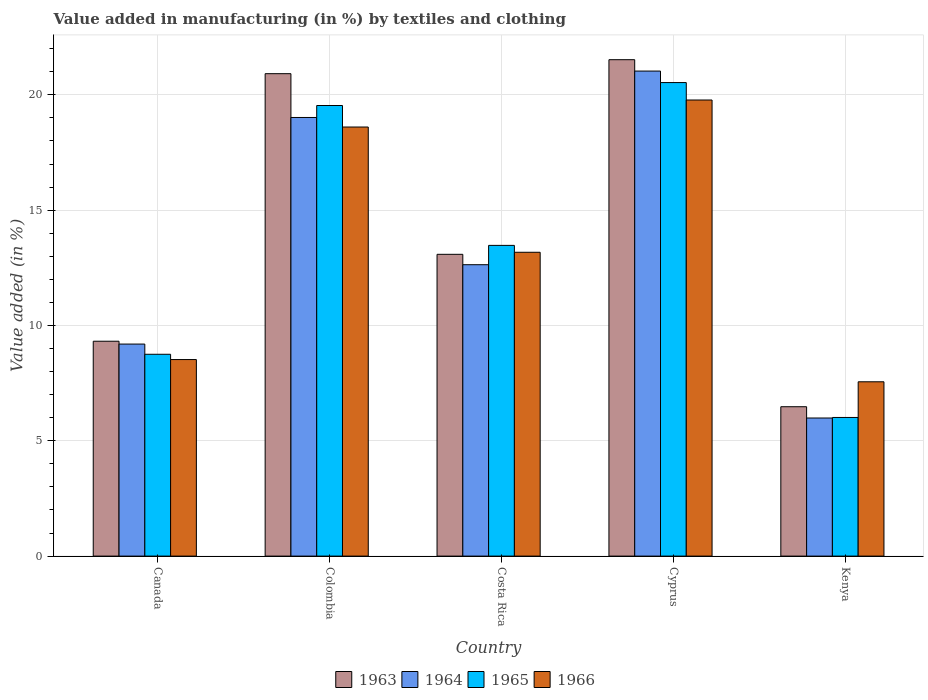Are the number of bars on each tick of the X-axis equal?
Your answer should be compact. Yes. How many bars are there on the 1st tick from the left?
Make the answer very short. 4. What is the label of the 4th group of bars from the left?
Offer a very short reply. Cyprus. What is the percentage of value added in manufacturing by textiles and clothing in 1963 in Cyprus?
Make the answer very short. 21.52. Across all countries, what is the maximum percentage of value added in manufacturing by textiles and clothing in 1966?
Your response must be concise. 19.78. Across all countries, what is the minimum percentage of value added in manufacturing by textiles and clothing in 1966?
Your answer should be very brief. 7.56. In which country was the percentage of value added in manufacturing by textiles and clothing in 1965 maximum?
Offer a terse response. Cyprus. In which country was the percentage of value added in manufacturing by textiles and clothing in 1966 minimum?
Provide a short and direct response. Kenya. What is the total percentage of value added in manufacturing by textiles and clothing in 1963 in the graph?
Your response must be concise. 71.32. What is the difference between the percentage of value added in manufacturing by textiles and clothing in 1966 in Canada and that in Costa Rica?
Ensure brevity in your answer.  -4.65. What is the difference between the percentage of value added in manufacturing by textiles and clothing in 1963 in Kenya and the percentage of value added in manufacturing by textiles and clothing in 1966 in Colombia?
Offer a terse response. -12.13. What is the average percentage of value added in manufacturing by textiles and clothing in 1964 per country?
Ensure brevity in your answer.  13.57. What is the difference between the percentage of value added in manufacturing by textiles and clothing of/in 1963 and percentage of value added in manufacturing by textiles and clothing of/in 1965 in Colombia?
Offer a terse response. 1.38. What is the ratio of the percentage of value added in manufacturing by textiles and clothing in 1966 in Colombia to that in Costa Rica?
Offer a terse response. 1.41. Is the difference between the percentage of value added in manufacturing by textiles and clothing in 1963 in Colombia and Kenya greater than the difference between the percentage of value added in manufacturing by textiles and clothing in 1965 in Colombia and Kenya?
Provide a short and direct response. Yes. What is the difference between the highest and the second highest percentage of value added in manufacturing by textiles and clothing in 1964?
Provide a short and direct response. 6.38. What is the difference between the highest and the lowest percentage of value added in manufacturing by textiles and clothing in 1965?
Provide a short and direct response. 14.52. Is it the case that in every country, the sum of the percentage of value added in manufacturing by textiles and clothing in 1965 and percentage of value added in manufacturing by textiles and clothing in 1966 is greater than the sum of percentage of value added in manufacturing by textiles and clothing in 1964 and percentage of value added in manufacturing by textiles and clothing in 1963?
Offer a very short reply. No. What does the 3rd bar from the left in Costa Rica represents?
Make the answer very short. 1965. What does the 3rd bar from the right in Costa Rica represents?
Offer a terse response. 1964. Is it the case that in every country, the sum of the percentage of value added in manufacturing by textiles and clothing in 1963 and percentage of value added in manufacturing by textiles and clothing in 1965 is greater than the percentage of value added in manufacturing by textiles and clothing in 1964?
Offer a very short reply. Yes. How many bars are there?
Offer a very short reply. 20. Are all the bars in the graph horizontal?
Offer a very short reply. No. Are the values on the major ticks of Y-axis written in scientific E-notation?
Make the answer very short. No. Does the graph contain grids?
Make the answer very short. Yes. How many legend labels are there?
Your answer should be very brief. 4. What is the title of the graph?
Provide a short and direct response. Value added in manufacturing (in %) by textiles and clothing. Does "1969" appear as one of the legend labels in the graph?
Your answer should be compact. No. What is the label or title of the X-axis?
Your answer should be compact. Country. What is the label or title of the Y-axis?
Provide a succinct answer. Value added (in %). What is the Value added (in %) of 1963 in Canada?
Your response must be concise. 9.32. What is the Value added (in %) of 1964 in Canada?
Your response must be concise. 9.19. What is the Value added (in %) of 1965 in Canada?
Keep it short and to the point. 8.75. What is the Value added (in %) in 1966 in Canada?
Make the answer very short. 8.52. What is the Value added (in %) of 1963 in Colombia?
Offer a very short reply. 20.92. What is the Value added (in %) of 1964 in Colombia?
Provide a short and direct response. 19.02. What is the Value added (in %) in 1965 in Colombia?
Your answer should be compact. 19.54. What is the Value added (in %) in 1966 in Colombia?
Keep it short and to the point. 18.6. What is the Value added (in %) in 1963 in Costa Rica?
Your answer should be very brief. 13.08. What is the Value added (in %) of 1964 in Costa Rica?
Make the answer very short. 12.63. What is the Value added (in %) in 1965 in Costa Rica?
Your response must be concise. 13.47. What is the Value added (in %) in 1966 in Costa Rica?
Give a very brief answer. 13.17. What is the Value added (in %) of 1963 in Cyprus?
Your answer should be compact. 21.52. What is the Value added (in %) in 1964 in Cyprus?
Provide a succinct answer. 21.03. What is the Value added (in %) of 1965 in Cyprus?
Offer a terse response. 20.53. What is the Value added (in %) in 1966 in Cyprus?
Keep it short and to the point. 19.78. What is the Value added (in %) of 1963 in Kenya?
Make the answer very short. 6.48. What is the Value added (in %) in 1964 in Kenya?
Provide a short and direct response. 5.99. What is the Value added (in %) of 1965 in Kenya?
Keep it short and to the point. 6.01. What is the Value added (in %) in 1966 in Kenya?
Offer a very short reply. 7.56. Across all countries, what is the maximum Value added (in %) in 1963?
Make the answer very short. 21.52. Across all countries, what is the maximum Value added (in %) in 1964?
Ensure brevity in your answer.  21.03. Across all countries, what is the maximum Value added (in %) of 1965?
Offer a terse response. 20.53. Across all countries, what is the maximum Value added (in %) of 1966?
Offer a terse response. 19.78. Across all countries, what is the minimum Value added (in %) of 1963?
Offer a terse response. 6.48. Across all countries, what is the minimum Value added (in %) of 1964?
Your answer should be very brief. 5.99. Across all countries, what is the minimum Value added (in %) of 1965?
Offer a terse response. 6.01. Across all countries, what is the minimum Value added (in %) of 1966?
Your answer should be compact. 7.56. What is the total Value added (in %) of 1963 in the graph?
Give a very brief answer. 71.32. What is the total Value added (in %) in 1964 in the graph?
Give a very brief answer. 67.86. What is the total Value added (in %) of 1965 in the graph?
Ensure brevity in your answer.  68.3. What is the total Value added (in %) in 1966 in the graph?
Provide a short and direct response. 67.63. What is the difference between the Value added (in %) in 1963 in Canada and that in Colombia?
Keep it short and to the point. -11.6. What is the difference between the Value added (in %) in 1964 in Canada and that in Colombia?
Offer a very short reply. -9.82. What is the difference between the Value added (in %) in 1965 in Canada and that in Colombia?
Offer a very short reply. -10.79. What is the difference between the Value added (in %) in 1966 in Canada and that in Colombia?
Make the answer very short. -10.08. What is the difference between the Value added (in %) of 1963 in Canada and that in Costa Rica?
Provide a succinct answer. -3.77. What is the difference between the Value added (in %) of 1964 in Canada and that in Costa Rica?
Your response must be concise. -3.44. What is the difference between the Value added (in %) of 1965 in Canada and that in Costa Rica?
Your response must be concise. -4.72. What is the difference between the Value added (in %) in 1966 in Canada and that in Costa Rica?
Offer a very short reply. -4.65. What is the difference between the Value added (in %) of 1963 in Canada and that in Cyprus?
Ensure brevity in your answer.  -12.21. What is the difference between the Value added (in %) of 1964 in Canada and that in Cyprus?
Your response must be concise. -11.84. What is the difference between the Value added (in %) in 1965 in Canada and that in Cyprus?
Provide a short and direct response. -11.78. What is the difference between the Value added (in %) in 1966 in Canada and that in Cyprus?
Your response must be concise. -11.25. What is the difference between the Value added (in %) in 1963 in Canada and that in Kenya?
Your answer should be compact. 2.84. What is the difference between the Value added (in %) in 1964 in Canada and that in Kenya?
Keep it short and to the point. 3.21. What is the difference between the Value added (in %) of 1965 in Canada and that in Kenya?
Give a very brief answer. 2.74. What is the difference between the Value added (in %) of 1966 in Canada and that in Kenya?
Offer a terse response. 0.96. What is the difference between the Value added (in %) in 1963 in Colombia and that in Costa Rica?
Your answer should be compact. 7.83. What is the difference between the Value added (in %) of 1964 in Colombia and that in Costa Rica?
Your answer should be compact. 6.38. What is the difference between the Value added (in %) of 1965 in Colombia and that in Costa Rica?
Provide a succinct answer. 6.06. What is the difference between the Value added (in %) of 1966 in Colombia and that in Costa Rica?
Make the answer very short. 5.43. What is the difference between the Value added (in %) in 1963 in Colombia and that in Cyprus?
Provide a short and direct response. -0.61. What is the difference between the Value added (in %) of 1964 in Colombia and that in Cyprus?
Ensure brevity in your answer.  -2.01. What is the difference between the Value added (in %) of 1965 in Colombia and that in Cyprus?
Ensure brevity in your answer.  -0.99. What is the difference between the Value added (in %) of 1966 in Colombia and that in Cyprus?
Provide a succinct answer. -1.17. What is the difference between the Value added (in %) of 1963 in Colombia and that in Kenya?
Offer a terse response. 14.44. What is the difference between the Value added (in %) in 1964 in Colombia and that in Kenya?
Give a very brief answer. 13.03. What is the difference between the Value added (in %) in 1965 in Colombia and that in Kenya?
Your answer should be compact. 13.53. What is the difference between the Value added (in %) in 1966 in Colombia and that in Kenya?
Offer a very short reply. 11.05. What is the difference between the Value added (in %) in 1963 in Costa Rica and that in Cyprus?
Offer a terse response. -8.44. What is the difference between the Value added (in %) in 1964 in Costa Rica and that in Cyprus?
Provide a succinct answer. -8.4. What is the difference between the Value added (in %) of 1965 in Costa Rica and that in Cyprus?
Your answer should be very brief. -7.06. What is the difference between the Value added (in %) in 1966 in Costa Rica and that in Cyprus?
Ensure brevity in your answer.  -6.6. What is the difference between the Value added (in %) of 1963 in Costa Rica and that in Kenya?
Your answer should be compact. 6.61. What is the difference between the Value added (in %) of 1964 in Costa Rica and that in Kenya?
Your answer should be compact. 6.65. What is the difference between the Value added (in %) in 1965 in Costa Rica and that in Kenya?
Provide a succinct answer. 7.46. What is the difference between the Value added (in %) of 1966 in Costa Rica and that in Kenya?
Your response must be concise. 5.62. What is the difference between the Value added (in %) in 1963 in Cyprus and that in Kenya?
Your answer should be very brief. 15.05. What is the difference between the Value added (in %) of 1964 in Cyprus and that in Kenya?
Ensure brevity in your answer.  15.04. What is the difference between the Value added (in %) in 1965 in Cyprus and that in Kenya?
Provide a short and direct response. 14.52. What is the difference between the Value added (in %) in 1966 in Cyprus and that in Kenya?
Offer a terse response. 12.22. What is the difference between the Value added (in %) in 1963 in Canada and the Value added (in %) in 1964 in Colombia?
Provide a succinct answer. -9.7. What is the difference between the Value added (in %) in 1963 in Canada and the Value added (in %) in 1965 in Colombia?
Ensure brevity in your answer.  -10.22. What is the difference between the Value added (in %) of 1963 in Canada and the Value added (in %) of 1966 in Colombia?
Your response must be concise. -9.29. What is the difference between the Value added (in %) in 1964 in Canada and the Value added (in %) in 1965 in Colombia?
Your answer should be compact. -10.34. What is the difference between the Value added (in %) of 1964 in Canada and the Value added (in %) of 1966 in Colombia?
Your answer should be very brief. -9.41. What is the difference between the Value added (in %) of 1965 in Canada and the Value added (in %) of 1966 in Colombia?
Make the answer very short. -9.85. What is the difference between the Value added (in %) in 1963 in Canada and the Value added (in %) in 1964 in Costa Rica?
Your answer should be very brief. -3.32. What is the difference between the Value added (in %) of 1963 in Canada and the Value added (in %) of 1965 in Costa Rica?
Give a very brief answer. -4.16. What is the difference between the Value added (in %) in 1963 in Canada and the Value added (in %) in 1966 in Costa Rica?
Provide a succinct answer. -3.86. What is the difference between the Value added (in %) in 1964 in Canada and the Value added (in %) in 1965 in Costa Rica?
Your response must be concise. -4.28. What is the difference between the Value added (in %) in 1964 in Canada and the Value added (in %) in 1966 in Costa Rica?
Make the answer very short. -3.98. What is the difference between the Value added (in %) in 1965 in Canada and the Value added (in %) in 1966 in Costa Rica?
Your answer should be very brief. -4.42. What is the difference between the Value added (in %) in 1963 in Canada and the Value added (in %) in 1964 in Cyprus?
Offer a terse response. -11.71. What is the difference between the Value added (in %) of 1963 in Canada and the Value added (in %) of 1965 in Cyprus?
Your answer should be very brief. -11.21. What is the difference between the Value added (in %) of 1963 in Canada and the Value added (in %) of 1966 in Cyprus?
Provide a short and direct response. -10.46. What is the difference between the Value added (in %) of 1964 in Canada and the Value added (in %) of 1965 in Cyprus?
Your answer should be compact. -11.34. What is the difference between the Value added (in %) in 1964 in Canada and the Value added (in %) in 1966 in Cyprus?
Provide a short and direct response. -10.58. What is the difference between the Value added (in %) in 1965 in Canada and the Value added (in %) in 1966 in Cyprus?
Make the answer very short. -11.02. What is the difference between the Value added (in %) in 1963 in Canada and the Value added (in %) in 1964 in Kenya?
Keep it short and to the point. 3.33. What is the difference between the Value added (in %) of 1963 in Canada and the Value added (in %) of 1965 in Kenya?
Ensure brevity in your answer.  3.31. What is the difference between the Value added (in %) of 1963 in Canada and the Value added (in %) of 1966 in Kenya?
Provide a short and direct response. 1.76. What is the difference between the Value added (in %) of 1964 in Canada and the Value added (in %) of 1965 in Kenya?
Your answer should be compact. 3.18. What is the difference between the Value added (in %) of 1964 in Canada and the Value added (in %) of 1966 in Kenya?
Your response must be concise. 1.64. What is the difference between the Value added (in %) in 1965 in Canada and the Value added (in %) in 1966 in Kenya?
Ensure brevity in your answer.  1.19. What is the difference between the Value added (in %) of 1963 in Colombia and the Value added (in %) of 1964 in Costa Rica?
Offer a terse response. 8.28. What is the difference between the Value added (in %) of 1963 in Colombia and the Value added (in %) of 1965 in Costa Rica?
Your answer should be compact. 7.44. What is the difference between the Value added (in %) of 1963 in Colombia and the Value added (in %) of 1966 in Costa Rica?
Your answer should be very brief. 7.74. What is the difference between the Value added (in %) of 1964 in Colombia and the Value added (in %) of 1965 in Costa Rica?
Provide a succinct answer. 5.55. What is the difference between the Value added (in %) in 1964 in Colombia and the Value added (in %) in 1966 in Costa Rica?
Keep it short and to the point. 5.84. What is the difference between the Value added (in %) of 1965 in Colombia and the Value added (in %) of 1966 in Costa Rica?
Your answer should be compact. 6.36. What is the difference between the Value added (in %) in 1963 in Colombia and the Value added (in %) in 1964 in Cyprus?
Give a very brief answer. -0.11. What is the difference between the Value added (in %) of 1963 in Colombia and the Value added (in %) of 1965 in Cyprus?
Ensure brevity in your answer.  0.39. What is the difference between the Value added (in %) of 1963 in Colombia and the Value added (in %) of 1966 in Cyprus?
Give a very brief answer. 1.14. What is the difference between the Value added (in %) in 1964 in Colombia and the Value added (in %) in 1965 in Cyprus?
Ensure brevity in your answer.  -1.51. What is the difference between the Value added (in %) of 1964 in Colombia and the Value added (in %) of 1966 in Cyprus?
Provide a succinct answer. -0.76. What is the difference between the Value added (in %) of 1965 in Colombia and the Value added (in %) of 1966 in Cyprus?
Make the answer very short. -0.24. What is the difference between the Value added (in %) in 1963 in Colombia and the Value added (in %) in 1964 in Kenya?
Your answer should be compact. 14.93. What is the difference between the Value added (in %) of 1963 in Colombia and the Value added (in %) of 1965 in Kenya?
Offer a very short reply. 14.91. What is the difference between the Value added (in %) of 1963 in Colombia and the Value added (in %) of 1966 in Kenya?
Keep it short and to the point. 13.36. What is the difference between the Value added (in %) of 1964 in Colombia and the Value added (in %) of 1965 in Kenya?
Give a very brief answer. 13.01. What is the difference between the Value added (in %) of 1964 in Colombia and the Value added (in %) of 1966 in Kenya?
Your response must be concise. 11.46. What is the difference between the Value added (in %) in 1965 in Colombia and the Value added (in %) in 1966 in Kenya?
Offer a very short reply. 11.98. What is the difference between the Value added (in %) of 1963 in Costa Rica and the Value added (in %) of 1964 in Cyprus?
Your answer should be very brief. -7.95. What is the difference between the Value added (in %) of 1963 in Costa Rica and the Value added (in %) of 1965 in Cyprus?
Your answer should be compact. -7.45. What is the difference between the Value added (in %) in 1963 in Costa Rica and the Value added (in %) in 1966 in Cyprus?
Offer a very short reply. -6.69. What is the difference between the Value added (in %) of 1964 in Costa Rica and the Value added (in %) of 1965 in Cyprus?
Keep it short and to the point. -7.9. What is the difference between the Value added (in %) in 1964 in Costa Rica and the Value added (in %) in 1966 in Cyprus?
Offer a very short reply. -7.14. What is the difference between the Value added (in %) of 1965 in Costa Rica and the Value added (in %) of 1966 in Cyprus?
Your answer should be compact. -6.3. What is the difference between the Value added (in %) in 1963 in Costa Rica and the Value added (in %) in 1964 in Kenya?
Ensure brevity in your answer.  7.1. What is the difference between the Value added (in %) in 1963 in Costa Rica and the Value added (in %) in 1965 in Kenya?
Your answer should be very brief. 7.07. What is the difference between the Value added (in %) of 1963 in Costa Rica and the Value added (in %) of 1966 in Kenya?
Keep it short and to the point. 5.53. What is the difference between the Value added (in %) in 1964 in Costa Rica and the Value added (in %) in 1965 in Kenya?
Give a very brief answer. 6.62. What is the difference between the Value added (in %) in 1964 in Costa Rica and the Value added (in %) in 1966 in Kenya?
Provide a succinct answer. 5.08. What is the difference between the Value added (in %) in 1965 in Costa Rica and the Value added (in %) in 1966 in Kenya?
Your response must be concise. 5.91. What is the difference between the Value added (in %) of 1963 in Cyprus and the Value added (in %) of 1964 in Kenya?
Provide a short and direct response. 15.54. What is the difference between the Value added (in %) in 1963 in Cyprus and the Value added (in %) in 1965 in Kenya?
Provide a succinct answer. 15.51. What is the difference between the Value added (in %) of 1963 in Cyprus and the Value added (in %) of 1966 in Kenya?
Your response must be concise. 13.97. What is the difference between the Value added (in %) in 1964 in Cyprus and the Value added (in %) in 1965 in Kenya?
Provide a short and direct response. 15.02. What is the difference between the Value added (in %) of 1964 in Cyprus and the Value added (in %) of 1966 in Kenya?
Ensure brevity in your answer.  13.47. What is the difference between the Value added (in %) in 1965 in Cyprus and the Value added (in %) in 1966 in Kenya?
Keep it short and to the point. 12.97. What is the average Value added (in %) of 1963 per country?
Make the answer very short. 14.26. What is the average Value added (in %) of 1964 per country?
Your answer should be very brief. 13.57. What is the average Value added (in %) of 1965 per country?
Your response must be concise. 13.66. What is the average Value added (in %) of 1966 per country?
Provide a succinct answer. 13.53. What is the difference between the Value added (in %) of 1963 and Value added (in %) of 1964 in Canada?
Give a very brief answer. 0.12. What is the difference between the Value added (in %) in 1963 and Value added (in %) in 1965 in Canada?
Your response must be concise. 0.57. What is the difference between the Value added (in %) in 1963 and Value added (in %) in 1966 in Canada?
Keep it short and to the point. 0.8. What is the difference between the Value added (in %) of 1964 and Value added (in %) of 1965 in Canada?
Your answer should be very brief. 0.44. What is the difference between the Value added (in %) in 1964 and Value added (in %) in 1966 in Canada?
Provide a succinct answer. 0.67. What is the difference between the Value added (in %) in 1965 and Value added (in %) in 1966 in Canada?
Keep it short and to the point. 0.23. What is the difference between the Value added (in %) in 1963 and Value added (in %) in 1964 in Colombia?
Ensure brevity in your answer.  1.9. What is the difference between the Value added (in %) of 1963 and Value added (in %) of 1965 in Colombia?
Provide a succinct answer. 1.38. What is the difference between the Value added (in %) in 1963 and Value added (in %) in 1966 in Colombia?
Provide a short and direct response. 2.31. What is the difference between the Value added (in %) in 1964 and Value added (in %) in 1965 in Colombia?
Offer a terse response. -0.52. What is the difference between the Value added (in %) in 1964 and Value added (in %) in 1966 in Colombia?
Provide a short and direct response. 0.41. What is the difference between the Value added (in %) in 1965 and Value added (in %) in 1966 in Colombia?
Provide a succinct answer. 0.93. What is the difference between the Value added (in %) of 1963 and Value added (in %) of 1964 in Costa Rica?
Your response must be concise. 0.45. What is the difference between the Value added (in %) in 1963 and Value added (in %) in 1965 in Costa Rica?
Give a very brief answer. -0.39. What is the difference between the Value added (in %) in 1963 and Value added (in %) in 1966 in Costa Rica?
Ensure brevity in your answer.  -0.09. What is the difference between the Value added (in %) of 1964 and Value added (in %) of 1965 in Costa Rica?
Ensure brevity in your answer.  -0.84. What is the difference between the Value added (in %) in 1964 and Value added (in %) in 1966 in Costa Rica?
Your answer should be very brief. -0.54. What is the difference between the Value added (in %) of 1965 and Value added (in %) of 1966 in Costa Rica?
Your answer should be very brief. 0.3. What is the difference between the Value added (in %) of 1963 and Value added (in %) of 1964 in Cyprus?
Your response must be concise. 0.49. What is the difference between the Value added (in %) of 1963 and Value added (in %) of 1966 in Cyprus?
Offer a terse response. 1.75. What is the difference between the Value added (in %) in 1964 and Value added (in %) in 1965 in Cyprus?
Provide a succinct answer. 0.5. What is the difference between the Value added (in %) in 1964 and Value added (in %) in 1966 in Cyprus?
Offer a very short reply. 1.25. What is the difference between the Value added (in %) of 1965 and Value added (in %) of 1966 in Cyprus?
Provide a short and direct response. 0.76. What is the difference between the Value added (in %) of 1963 and Value added (in %) of 1964 in Kenya?
Your answer should be very brief. 0.49. What is the difference between the Value added (in %) of 1963 and Value added (in %) of 1965 in Kenya?
Your answer should be very brief. 0.47. What is the difference between the Value added (in %) in 1963 and Value added (in %) in 1966 in Kenya?
Offer a terse response. -1.08. What is the difference between the Value added (in %) of 1964 and Value added (in %) of 1965 in Kenya?
Provide a succinct answer. -0.02. What is the difference between the Value added (in %) of 1964 and Value added (in %) of 1966 in Kenya?
Make the answer very short. -1.57. What is the difference between the Value added (in %) in 1965 and Value added (in %) in 1966 in Kenya?
Keep it short and to the point. -1.55. What is the ratio of the Value added (in %) in 1963 in Canada to that in Colombia?
Provide a short and direct response. 0.45. What is the ratio of the Value added (in %) in 1964 in Canada to that in Colombia?
Your response must be concise. 0.48. What is the ratio of the Value added (in %) of 1965 in Canada to that in Colombia?
Your answer should be compact. 0.45. What is the ratio of the Value added (in %) of 1966 in Canada to that in Colombia?
Ensure brevity in your answer.  0.46. What is the ratio of the Value added (in %) in 1963 in Canada to that in Costa Rica?
Provide a short and direct response. 0.71. What is the ratio of the Value added (in %) in 1964 in Canada to that in Costa Rica?
Offer a very short reply. 0.73. What is the ratio of the Value added (in %) in 1965 in Canada to that in Costa Rica?
Provide a succinct answer. 0.65. What is the ratio of the Value added (in %) of 1966 in Canada to that in Costa Rica?
Offer a terse response. 0.65. What is the ratio of the Value added (in %) of 1963 in Canada to that in Cyprus?
Give a very brief answer. 0.43. What is the ratio of the Value added (in %) in 1964 in Canada to that in Cyprus?
Your answer should be very brief. 0.44. What is the ratio of the Value added (in %) of 1965 in Canada to that in Cyprus?
Give a very brief answer. 0.43. What is the ratio of the Value added (in %) in 1966 in Canada to that in Cyprus?
Provide a succinct answer. 0.43. What is the ratio of the Value added (in %) of 1963 in Canada to that in Kenya?
Provide a succinct answer. 1.44. What is the ratio of the Value added (in %) in 1964 in Canada to that in Kenya?
Ensure brevity in your answer.  1.54. What is the ratio of the Value added (in %) in 1965 in Canada to that in Kenya?
Give a very brief answer. 1.46. What is the ratio of the Value added (in %) in 1966 in Canada to that in Kenya?
Keep it short and to the point. 1.13. What is the ratio of the Value added (in %) in 1963 in Colombia to that in Costa Rica?
Offer a very short reply. 1.6. What is the ratio of the Value added (in %) of 1964 in Colombia to that in Costa Rica?
Your response must be concise. 1.51. What is the ratio of the Value added (in %) of 1965 in Colombia to that in Costa Rica?
Your answer should be compact. 1.45. What is the ratio of the Value added (in %) in 1966 in Colombia to that in Costa Rica?
Give a very brief answer. 1.41. What is the ratio of the Value added (in %) in 1963 in Colombia to that in Cyprus?
Ensure brevity in your answer.  0.97. What is the ratio of the Value added (in %) of 1964 in Colombia to that in Cyprus?
Provide a short and direct response. 0.9. What is the ratio of the Value added (in %) of 1965 in Colombia to that in Cyprus?
Make the answer very short. 0.95. What is the ratio of the Value added (in %) in 1966 in Colombia to that in Cyprus?
Give a very brief answer. 0.94. What is the ratio of the Value added (in %) of 1963 in Colombia to that in Kenya?
Ensure brevity in your answer.  3.23. What is the ratio of the Value added (in %) of 1964 in Colombia to that in Kenya?
Your answer should be very brief. 3.18. What is the ratio of the Value added (in %) in 1966 in Colombia to that in Kenya?
Offer a terse response. 2.46. What is the ratio of the Value added (in %) in 1963 in Costa Rica to that in Cyprus?
Make the answer very short. 0.61. What is the ratio of the Value added (in %) in 1964 in Costa Rica to that in Cyprus?
Ensure brevity in your answer.  0.6. What is the ratio of the Value added (in %) of 1965 in Costa Rica to that in Cyprus?
Your response must be concise. 0.66. What is the ratio of the Value added (in %) in 1966 in Costa Rica to that in Cyprus?
Ensure brevity in your answer.  0.67. What is the ratio of the Value added (in %) of 1963 in Costa Rica to that in Kenya?
Make the answer very short. 2.02. What is the ratio of the Value added (in %) of 1964 in Costa Rica to that in Kenya?
Provide a succinct answer. 2.11. What is the ratio of the Value added (in %) in 1965 in Costa Rica to that in Kenya?
Your answer should be compact. 2.24. What is the ratio of the Value added (in %) in 1966 in Costa Rica to that in Kenya?
Ensure brevity in your answer.  1.74. What is the ratio of the Value added (in %) in 1963 in Cyprus to that in Kenya?
Your answer should be very brief. 3.32. What is the ratio of the Value added (in %) of 1964 in Cyprus to that in Kenya?
Your answer should be very brief. 3.51. What is the ratio of the Value added (in %) in 1965 in Cyprus to that in Kenya?
Your answer should be compact. 3.42. What is the ratio of the Value added (in %) in 1966 in Cyprus to that in Kenya?
Make the answer very short. 2.62. What is the difference between the highest and the second highest Value added (in %) in 1963?
Provide a short and direct response. 0.61. What is the difference between the highest and the second highest Value added (in %) in 1964?
Your answer should be very brief. 2.01. What is the difference between the highest and the second highest Value added (in %) in 1966?
Give a very brief answer. 1.17. What is the difference between the highest and the lowest Value added (in %) of 1963?
Your answer should be very brief. 15.05. What is the difference between the highest and the lowest Value added (in %) of 1964?
Provide a succinct answer. 15.04. What is the difference between the highest and the lowest Value added (in %) of 1965?
Keep it short and to the point. 14.52. What is the difference between the highest and the lowest Value added (in %) in 1966?
Ensure brevity in your answer.  12.22. 